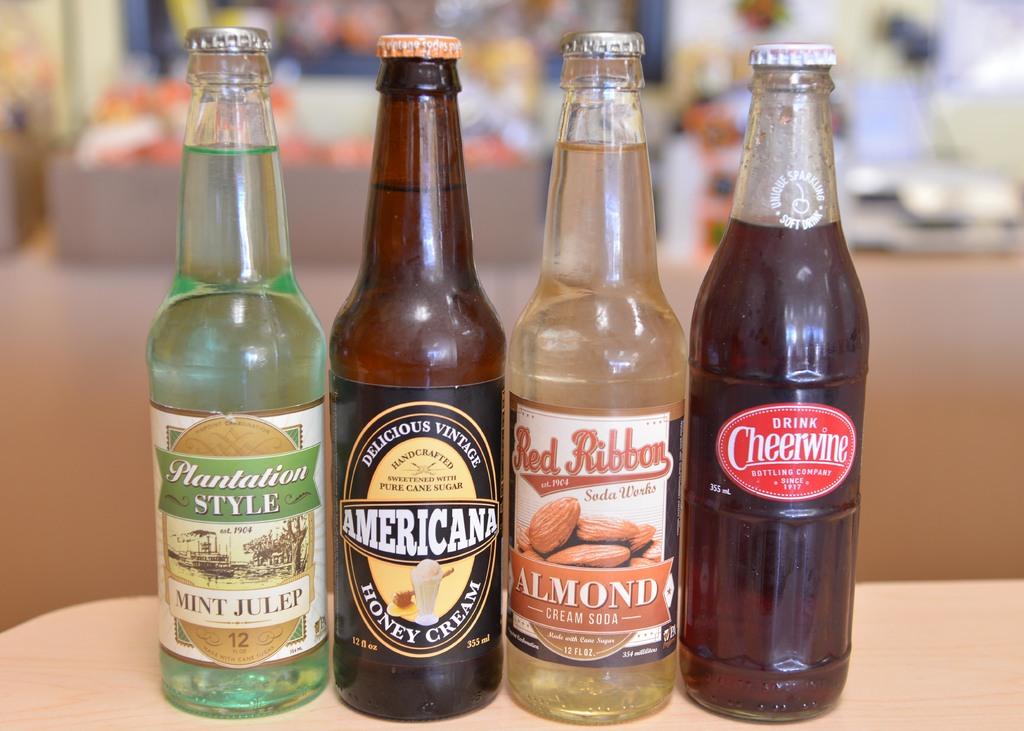What flavor is the plantation style drink?
Offer a very short reply. Mint julep. 